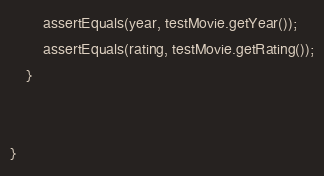Convert code to text. <code><loc_0><loc_0><loc_500><loc_500><_Java_>        assertEquals(year, testMovie.getYear());
        assertEquals(rating, testMovie.getRating());
    }


}
</code> 